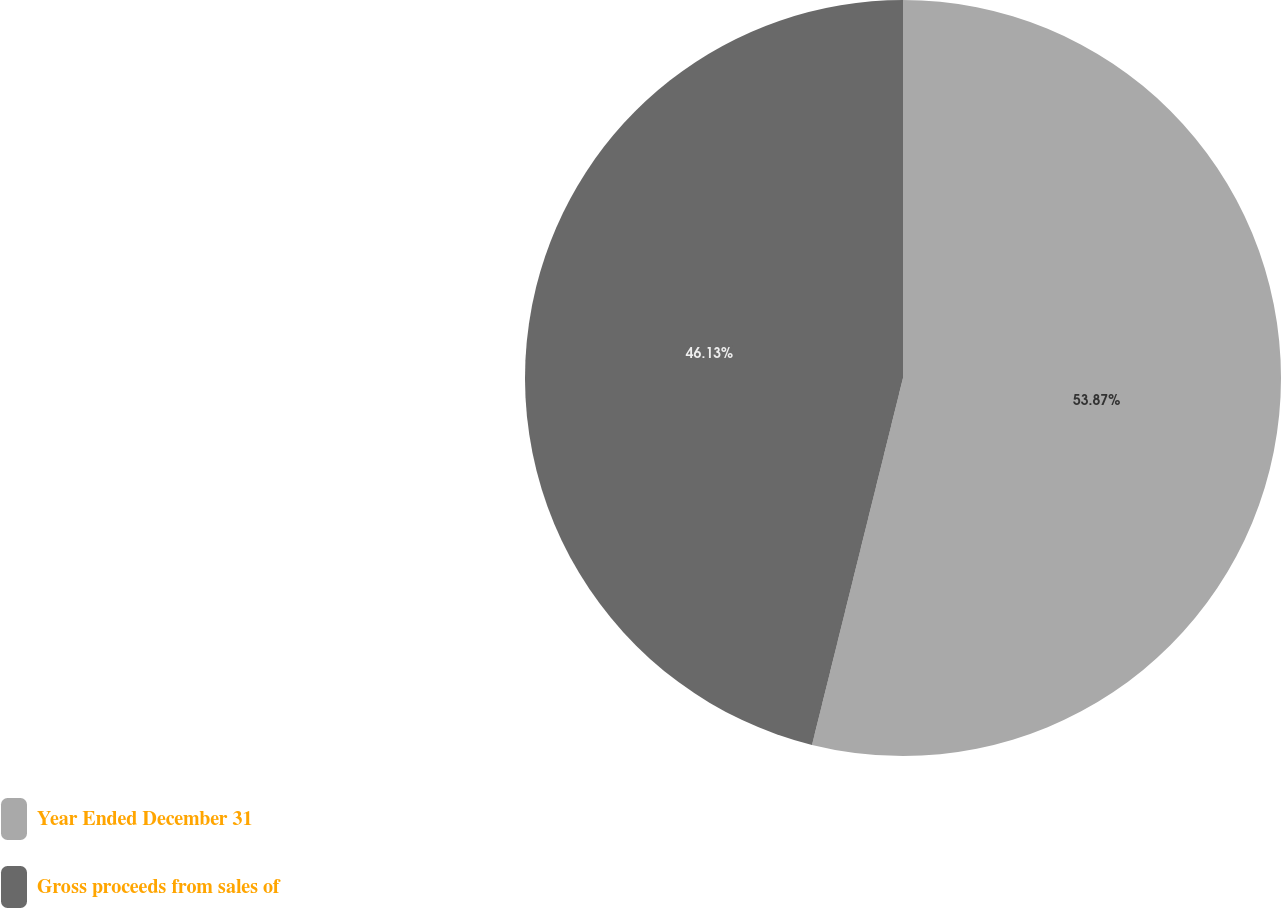<chart> <loc_0><loc_0><loc_500><loc_500><pie_chart><fcel>Year Ended December 31<fcel>Gross proceeds from sales of<nl><fcel>53.87%<fcel>46.13%<nl></chart> 